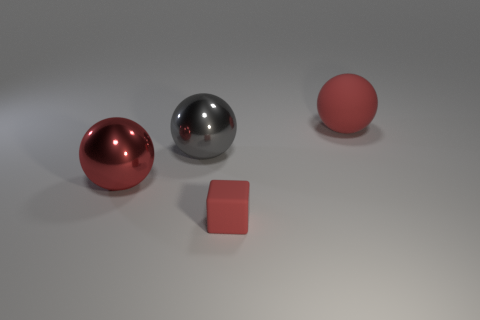What number of objects are things on the left side of the big red matte ball or red balls?
Your response must be concise. 4. There is a object to the right of the red rubber thing left of the red ball right of the large red metal sphere; what shape is it?
Give a very brief answer. Sphere. What number of tiny objects are the same shape as the large gray thing?
Give a very brief answer. 0. What material is the small thing that is the same color as the large matte object?
Offer a very short reply. Rubber. Is the big gray object made of the same material as the tiny red block?
Keep it short and to the point. No. What number of large balls are in front of the large red thing that is on the right side of the tiny red cube that is in front of the big gray thing?
Make the answer very short. 2. Are there any spheres made of the same material as the red block?
Keep it short and to the point. Yes. There is a rubber object that is the same color as the matte ball; what size is it?
Keep it short and to the point. Small. Are there fewer blue metallic blocks than big red metallic objects?
Your response must be concise. Yes. Do the shiny ball that is on the right side of the red shiny thing and the small object have the same color?
Provide a succinct answer. No. 